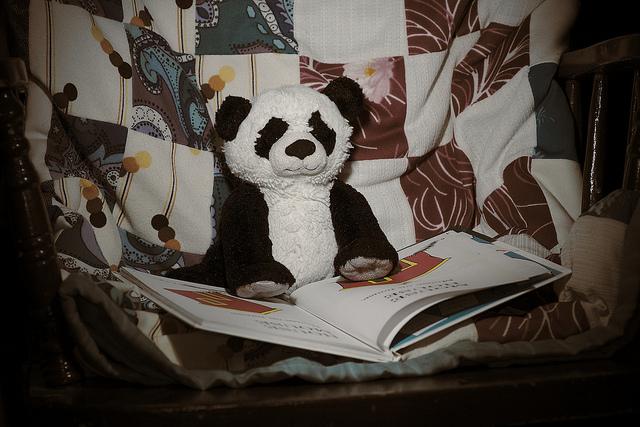What is reading the book?
Give a very brief answer. Panda. What would a human do with the object the bear holds?
Give a very brief answer. Read. What is the name of the book?
Write a very short answer. Teddy. 